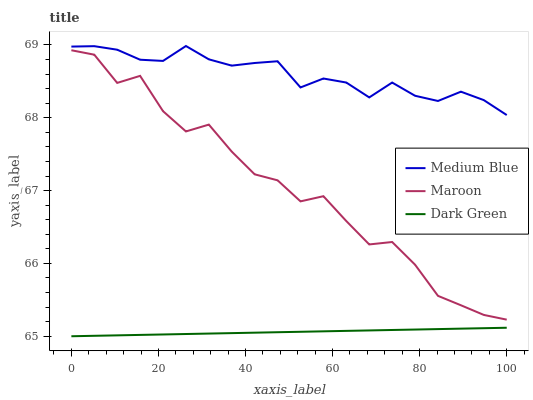Does Dark Green have the minimum area under the curve?
Answer yes or no. Yes. Does Medium Blue have the maximum area under the curve?
Answer yes or no. Yes. Does Maroon have the minimum area under the curve?
Answer yes or no. No. Does Maroon have the maximum area under the curve?
Answer yes or no. No. Is Dark Green the smoothest?
Answer yes or no. Yes. Is Maroon the roughest?
Answer yes or no. Yes. Is Maroon the smoothest?
Answer yes or no. No. Is Dark Green the roughest?
Answer yes or no. No. Does Dark Green have the lowest value?
Answer yes or no. Yes. Does Maroon have the lowest value?
Answer yes or no. No. Does Medium Blue have the highest value?
Answer yes or no. Yes. Does Maroon have the highest value?
Answer yes or no. No. Is Maroon less than Medium Blue?
Answer yes or no. Yes. Is Maroon greater than Dark Green?
Answer yes or no. Yes. Does Maroon intersect Medium Blue?
Answer yes or no. No. 